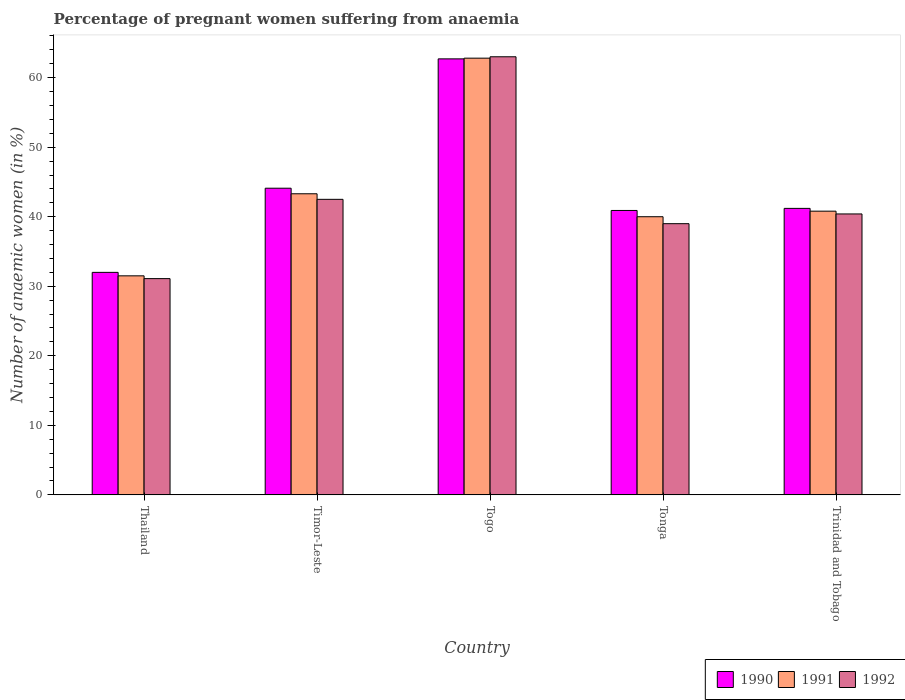How many groups of bars are there?
Your response must be concise. 5. Are the number of bars per tick equal to the number of legend labels?
Your response must be concise. Yes. Are the number of bars on each tick of the X-axis equal?
Your answer should be compact. Yes. How many bars are there on the 1st tick from the left?
Make the answer very short. 3. What is the label of the 3rd group of bars from the left?
Offer a very short reply. Togo. In how many cases, is the number of bars for a given country not equal to the number of legend labels?
Your answer should be compact. 0. Across all countries, what is the minimum number of anaemic women in 1990?
Your response must be concise. 32. In which country was the number of anaemic women in 1992 maximum?
Provide a succinct answer. Togo. In which country was the number of anaemic women in 1991 minimum?
Provide a succinct answer. Thailand. What is the total number of anaemic women in 1991 in the graph?
Your response must be concise. 218.4. What is the difference between the number of anaemic women in 1992 in Thailand and the number of anaemic women in 1991 in Tonga?
Give a very brief answer. -8.9. What is the average number of anaemic women in 1991 per country?
Offer a very short reply. 43.68. What is the difference between the number of anaemic women of/in 1990 and number of anaemic women of/in 1991 in Togo?
Provide a succinct answer. -0.1. In how many countries, is the number of anaemic women in 1991 greater than 48 %?
Ensure brevity in your answer.  1. What is the ratio of the number of anaemic women in 1991 in Thailand to that in Timor-Leste?
Provide a succinct answer. 0.73. What is the difference between the highest and the second highest number of anaemic women in 1990?
Give a very brief answer. -2.9. What is the difference between the highest and the lowest number of anaemic women in 1990?
Provide a short and direct response. 30.7. What does the 1st bar from the left in Trinidad and Tobago represents?
Make the answer very short. 1990. Is it the case that in every country, the sum of the number of anaemic women in 1991 and number of anaemic women in 1990 is greater than the number of anaemic women in 1992?
Offer a very short reply. Yes. How many bars are there?
Offer a terse response. 15. Are all the bars in the graph horizontal?
Provide a short and direct response. No. How many countries are there in the graph?
Provide a short and direct response. 5. Does the graph contain grids?
Your answer should be very brief. No. Where does the legend appear in the graph?
Your answer should be very brief. Bottom right. How many legend labels are there?
Ensure brevity in your answer.  3. What is the title of the graph?
Provide a succinct answer. Percentage of pregnant women suffering from anaemia. Does "1984" appear as one of the legend labels in the graph?
Provide a succinct answer. No. What is the label or title of the X-axis?
Make the answer very short. Country. What is the label or title of the Y-axis?
Give a very brief answer. Number of anaemic women (in %). What is the Number of anaemic women (in %) of 1990 in Thailand?
Your answer should be very brief. 32. What is the Number of anaemic women (in %) of 1991 in Thailand?
Keep it short and to the point. 31.5. What is the Number of anaemic women (in %) in 1992 in Thailand?
Offer a very short reply. 31.1. What is the Number of anaemic women (in %) in 1990 in Timor-Leste?
Keep it short and to the point. 44.1. What is the Number of anaemic women (in %) of 1991 in Timor-Leste?
Give a very brief answer. 43.3. What is the Number of anaemic women (in %) of 1992 in Timor-Leste?
Provide a short and direct response. 42.5. What is the Number of anaemic women (in %) of 1990 in Togo?
Provide a succinct answer. 62.7. What is the Number of anaemic women (in %) in 1991 in Togo?
Give a very brief answer. 62.8. What is the Number of anaemic women (in %) in 1990 in Tonga?
Ensure brevity in your answer.  40.9. What is the Number of anaemic women (in %) in 1990 in Trinidad and Tobago?
Ensure brevity in your answer.  41.2. What is the Number of anaemic women (in %) in 1991 in Trinidad and Tobago?
Your answer should be compact. 40.8. What is the Number of anaemic women (in %) of 1992 in Trinidad and Tobago?
Make the answer very short. 40.4. Across all countries, what is the maximum Number of anaemic women (in %) of 1990?
Offer a very short reply. 62.7. Across all countries, what is the maximum Number of anaemic women (in %) in 1991?
Make the answer very short. 62.8. Across all countries, what is the maximum Number of anaemic women (in %) in 1992?
Give a very brief answer. 63. Across all countries, what is the minimum Number of anaemic women (in %) of 1991?
Provide a succinct answer. 31.5. Across all countries, what is the minimum Number of anaemic women (in %) of 1992?
Give a very brief answer. 31.1. What is the total Number of anaemic women (in %) in 1990 in the graph?
Your answer should be compact. 220.9. What is the total Number of anaemic women (in %) of 1991 in the graph?
Offer a very short reply. 218.4. What is the total Number of anaemic women (in %) in 1992 in the graph?
Provide a short and direct response. 216. What is the difference between the Number of anaemic women (in %) in 1992 in Thailand and that in Timor-Leste?
Your answer should be compact. -11.4. What is the difference between the Number of anaemic women (in %) in 1990 in Thailand and that in Togo?
Keep it short and to the point. -30.7. What is the difference between the Number of anaemic women (in %) of 1991 in Thailand and that in Togo?
Keep it short and to the point. -31.3. What is the difference between the Number of anaemic women (in %) of 1992 in Thailand and that in Togo?
Provide a succinct answer. -31.9. What is the difference between the Number of anaemic women (in %) in 1990 in Thailand and that in Tonga?
Offer a very short reply. -8.9. What is the difference between the Number of anaemic women (in %) of 1992 in Thailand and that in Tonga?
Give a very brief answer. -7.9. What is the difference between the Number of anaemic women (in %) in 1990 in Thailand and that in Trinidad and Tobago?
Your response must be concise. -9.2. What is the difference between the Number of anaemic women (in %) in 1992 in Thailand and that in Trinidad and Tobago?
Your response must be concise. -9.3. What is the difference between the Number of anaemic women (in %) of 1990 in Timor-Leste and that in Togo?
Provide a short and direct response. -18.6. What is the difference between the Number of anaemic women (in %) of 1991 in Timor-Leste and that in Togo?
Make the answer very short. -19.5. What is the difference between the Number of anaemic women (in %) in 1992 in Timor-Leste and that in Togo?
Your answer should be very brief. -20.5. What is the difference between the Number of anaemic women (in %) in 1991 in Timor-Leste and that in Tonga?
Your answer should be compact. 3.3. What is the difference between the Number of anaemic women (in %) in 1992 in Timor-Leste and that in Trinidad and Tobago?
Keep it short and to the point. 2.1. What is the difference between the Number of anaemic women (in %) in 1990 in Togo and that in Tonga?
Provide a short and direct response. 21.8. What is the difference between the Number of anaemic women (in %) in 1991 in Togo and that in Tonga?
Make the answer very short. 22.8. What is the difference between the Number of anaemic women (in %) in 1992 in Togo and that in Tonga?
Keep it short and to the point. 24. What is the difference between the Number of anaemic women (in %) of 1990 in Togo and that in Trinidad and Tobago?
Offer a terse response. 21.5. What is the difference between the Number of anaemic women (in %) of 1991 in Togo and that in Trinidad and Tobago?
Keep it short and to the point. 22. What is the difference between the Number of anaemic women (in %) of 1992 in Togo and that in Trinidad and Tobago?
Ensure brevity in your answer.  22.6. What is the difference between the Number of anaemic women (in %) of 1990 in Tonga and that in Trinidad and Tobago?
Your answer should be compact. -0.3. What is the difference between the Number of anaemic women (in %) in 1991 in Tonga and that in Trinidad and Tobago?
Give a very brief answer. -0.8. What is the difference between the Number of anaemic women (in %) of 1992 in Tonga and that in Trinidad and Tobago?
Provide a succinct answer. -1.4. What is the difference between the Number of anaemic women (in %) in 1990 in Thailand and the Number of anaemic women (in %) in 1991 in Togo?
Provide a succinct answer. -30.8. What is the difference between the Number of anaemic women (in %) in 1990 in Thailand and the Number of anaemic women (in %) in 1992 in Togo?
Your answer should be compact. -31. What is the difference between the Number of anaemic women (in %) of 1991 in Thailand and the Number of anaemic women (in %) of 1992 in Togo?
Your answer should be compact. -31.5. What is the difference between the Number of anaemic women (in %) of 1990 in Thailand and the Number of anaemic women (in %) of 1991 in Tonga?
Offer a very short reply. -8. What is the difference between the Number of anaemic women (in %) of 1990 in Thailand and the Number of anaemic women (in %) of 1991 in Trinidad and Tobago?
Give a very brief answer. -8.8. What is the difference between the Number of anaemic women (in %) of 1990 in Timor-Leste and the Number of anaemic women (in %) of 1991 in Togo?
Keep it short and to the point. -18.7. What is the difference between the Number of anaemic women (in %) in 1990 in Timor-Leste and the Number of anaemic women (in %) in 1992 in Togo?
Provide a short and direct response. -18.9. What is the difference between the Number of anaemic women (in %) of 1991 in Timor-Leste and the Number of anaemic women (in %) of 1992 in Togo?
Provide a succinct answer. -19.7. What is the difference between the Number of anaemic women (in %) in 1991 in Timor-Leste and the Number of anaemic women (in %) in 1992 in Tonga?
Ensure brevity in your answer.  4.3. What is the difference between the Number of anaemic women (in %) of 1990 in Timor-Leste and the Number of anaemic women (in %) of 1992 in Trinidad and Tobago?
Ensure brevity in your answer.  3.7. What is the difference between the Number of anaemic women (in %) of 1991 in Timor-Leste and the Number of anaemic women (in %) of 1992 in Trinidad and Tobago?
Your response must be concise. 2.9. What is the difference between the Number of anaemic women (in %) in 1990 in Togo and the Number of anaemic women (in %) in 1991 in Tonga?
Make the answer very short. 22.7. What is the difference between the Number of anaemic women (in %) of 1990 in Togo and the Number of anaemic women (in %) of 1992 in Tonga?
Provide a short and direct response. 23.7. What is the difference between the Number of anaemic women (in %) in 1991 in Togo and the Number of anaemic women (in %) in 1992 in Tonga?
Give a very brief answer. 23.8. What is the difference between the Number of anaemic women (in %) of 1990 in Togo and the Number of anaemic women (in %) of 1991 in Trinidad and Tobago?
Ensure brevity in your answer.  21.9. What is the difference between the Number of anaemic women (in %) in 1990 in Togo and the Number of anaemic women (in %) in 1992 in Trinidad and Tobago?
Ensure brevity in your answer.  22.3. What is the difference between the Number of anaemic women (in %) in 1991 in Togo and the Number of anaemic women (in %) in 1992 in Trinidad and Tobago?
Make the answer very short. 22.4. What is the difference between the Number of anaemic women (in %) of 1990 in Tonga and the Number of anaemic women (in %) of 1991 in Trinidad and Tobago?
Provide a succinct answer. 0.1. What is the average Number of anaemic women (in %) of 1990 per country?
Offer a terse response. 44.18. What is the average Number of anaemic women (in %) of 1991 per country?
Offer a very short reply. 43.68. What is the average Number of anaemic women (in %) in 1992 per country?
Your response must be concise. 43.2. What is the difference between the Number of anaemic women (in %) of 1990 and Number of anaemic women (in %) of 1991 in Thailand?
Your response must be concise. 0.5. What is the difference between the Number of anaemic women (in %) of 1990 and Number of anaemic women (in %) of 1992 in Thailand?
Provide a succinct answer. 0.9. What is the difference between the Number of anaemic women (in %) in 1990 and Number of anaemic women (in %) in 1991 in Timor-Leste?
Offer a very short reply. 0.8. What is the difference between the Number of anaemic women (in %) in 1990 and Number of anaemic women (in %) in 1992 in Timor-Leste?
Your answer should be compact. 1.6. What is the difference between the Number of anaemic women (in %) in 1991 and Number of anaemic women (in %) in 1992 in Timor-Leste?
Give a very brief answer. 0.8. What is the difference between the Number of anaemic women (in %) of 1990 and Number of anaemic women (in %) of 1992 in Togo?
Provide a succinct answer. -0.3. What is the difference between the Number of anaemic women (in %) of 1991 and Number of anaemic women (in %) of 1992 in Togo?
Keep it short and to the point. -0.2. What is the difference between the Number of anaemic women (in %) in 1990 and Number of anaemic women (in %) in 1991 in Tonga?
Offer a terse response. 0.9. What is the difference between the Number of anaemic women (in %) of 1990 and Number of anaemic women (in %) of 1992 in Tonga?
Your response must be concise. 1.9. What is the difference between the Number of anaemic women (in %) in 1991 and Number of anaemic women (in %) in 1992 in Trinidad and Tobago?
Provide a succinct answer. 0.4. What is the ratio of the Number of anaemic women (in %) of 1990 in Thailand to that in Timor-Leste?
Offer a terse response. 0.73. What is the ratio of the Number of anaemic women (in %) in 1991 in Thailand to that in Timor-Leste?
Ensure brevity in your answer.  0.73. What is the ratio of the Number of anaemic women (in %) in 1992 in Thailand to that in Timor-Leste?
Offer a terse response. 0.73. What is the ratio of the Number of anaemic women (in %) in 1990 in Thailand to that in Togo?
Give a very brief answer. 0.51. What is the ratio of the Number of anaemic women (in %) in 1991 in Thailand to that in Togo?
Offer a terse response. 0.5. What is the ratio of the Number of anaemic women (in %) of 1992 in Thailand to that in Togo?
Your response must be concise. 0.49. What is the ratio of the Number of anaemic women (in %) of 1990 in Thailand to that in Tonga?
Your answer should be very brief. 0.78. What is the ratio of the Number of anaemic women (in %) in 1991 in Thailand to that in Tonga?
Your answer should be very brief. 0.79. What is the ratio of the Number of anaemic women (in %) of 1992 in Thailand to that in Tonga?
Provide a short and direct response. 0.8. What is the ratio of the Number of anaemic women (in %) in 1990 in Thailand to that in Trinidad and Tobago?
Keep it short and to the point. 0.78. What is the ratio of the Number of anaemic women (in %) in 1991 in Thailand to that in Trinidad and Tobago?
Make the answer very short. 0.77. What is the ratio of the Number of anaemic women (in %) of 1992 in Thailand to that in Trinidad and Tobago?
Your answer should be compact. 0.77. What is the ratio of the Number of anaemic women (in %) in 1990 in Timor-Leste to that in Togo?
Ensure brevity in your answer.  0.7. What is the ratio of the Number of anaemic women (in %) in 1991 in Timor-Leste to that in Togo?
Your answer should be compact. 0.69. What is the ratio of the Number of anaemic women (in %) of 1992 in Timor-Leste to that in Togo?
Provide a short and direct response. 0.67. What is the ratio of the Number of anaemic women (in %) in 1990 in Timor-Leste to that in Tonga?
Your answer should be compact. 1.08. What is the ratio of the Number of anaemic women (in %) of 1991 in Timor-Leste to that in Tonga?
Keep it short and to the point. 1.08. What is the ratio of the Number of anaemic women (in %) in 1992 in Timor-Leste to that in Tonga?
Make the answer very short. 1.09. What is the ratio of the Number of anaemic women (in %) of 1990 in Timor-Leste to that in Trinidad and Tobago?
Your response must be concise. 1.07. What is the ratio of the Number of anaemic women (in %) in 1991 in Timor-Leste to that in Trinidad and Tobago?
Provide a short and direct response. 1.06. What is the ratio of the Number of anaemic women (in %) of 1992 in Timor-Leste to that in Trinidad and Tobago?
Your answer should be very brief. 1.05. What is the ratio of the Number of anaemic women (in %) of 1990 in Togo to that in Tonga?
Offer a very short reply. 1.53. What is the ratio of the Number of anaemic women (in %) of 1991 in Togo to that in Tonga?
Your answer should be compact. 1.57. What is the ratio of the Number of anaemic women (in %) in 1992 in Togo to that in Tonga?
Make the answer very short. 1.62. What is the ratio of the Number of anaemic women (in %) in 1990 in Togo to that in Trinidad and Tobago?
Your response must be concise. 1.52. What is the ratio of the Number of anaemic women (in %) of 1991 in Togo to that in Trinidad and Tobago?
Your answer should be compact. 1.54. What is the ratio of the Number of anaemic women (in %) in 1992 in Togo to that in Trinidad and Tobago?
Provide a succinct answer. 1.56. What is the ratio of the Number of anaemic women (in %) in 1990 in Tonga to that in Trinidad and Tobago?
Your answer should be compact. 0.99. What is the ratio of the Number of anaemic women (in %) of 1991 in Tonga to that in Trinidad and Tobago?
Offer a terse response. 0.98. What is the ratio of the Number of anaemic women (in %) of 1992 in Tonga to that in Trinidad and Tobago?
Offer a terse response. 0.97. What is the difference between the highest and the second highest Number of anaemic women (in %) of 1991?
Give a very brief answer. 19.5. What is the difference between the highest and the second highest Number of anaemic women (in %) of 1992?
Give a very brief answer. 20.5. What is the difference between the highest and the lowest Number of anaemic women (in %) of 1990?
Your response must be concise. 30.7. What is the difference between the highest and the lowest Number of anaemic women (in %) of 1991?
Ensure brevity in your answer.  31.3. What is the difference between the highest and the lowest Number of anaemic women (in %) in 1992?
Your answer should be very brief. 31.9. 